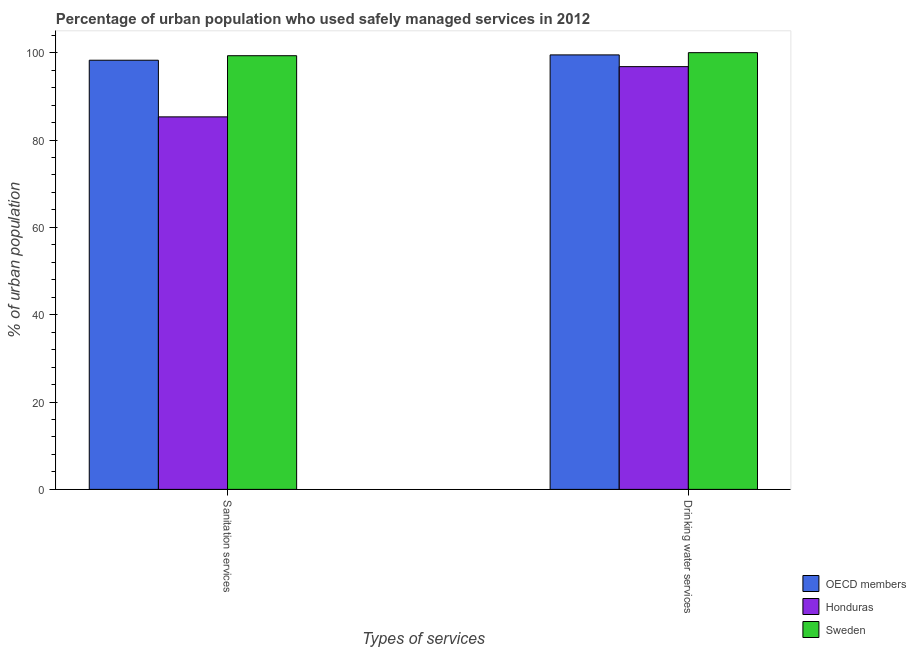How many different coloured bars are there?
Offer a very short reply. 3. How many groups of bars are there?
Offer a very short reply. 2. Are the number of bars per tick equal to the number of legend labels?
Keep it short and to the point. Yes. What is the label of the 2nd group of bars from the left?
Give a very brief answer. Drinking water services. What is the percentage of urban population who used sanitation services in Honduras?
Your response must be concise. 85.3. Across all countries, what is the maximum percentage of urban population who used sanitation services?
Your response must be concise. 99.3. Across all countries, what is the minimum percentage of urban population who used sanitation services?
Ensure brevity in your answer.  85.3. In which country was the percentage of urban population who used drinking water services minimum?
Give a very brief answer. Honduras. What is the total percentage of urban population who used sanitation services in the graph?
Your response must be concise. 282.87. What is the difference between the percentage of urban population who used drinking water services in Sweden and that in Honduras?
Give a very brief answer. 3.2. What is the average percentage of urban population who used sanitation services per country?
Keep it short and to the point. 94.29. What is the difference between the percentage of urban population who used sanitation services and percentage of urban population who used drinking water services in Sweden?
Your answer should be compact. -0.7. In how many countries, is the percentage of urban population who used sanitation services greater than 32 %?
Your answer should be very brief. 3. What is the ratio of the percentage of urban population who used sanitation services in Honduras to that in OECD members?
Keep it short and to the point. 0.87. What does the 2nd bar from the left in Sanitation services represents?
Make the answer very short. Honduras. What does the 2nd bar from the right in Sanitation services represents?
Keep it short and to the point. Honduras. How many countries are there in the graph?
Ensure brevity in your answer.  3. What is the difference between two consecutive major ticks on the Y-axis?
Offer a terse response. 20. Are the values on the major ticks of Y-axis written in scientific E-notation?
Keep it short and to the point. No. Does the graph contain any zero values?
Keep it short and to the point. No. Does the graph contain grids?
Offer a terse response. No. Where does the legend appear in the graph?
Offer a very short reply. Bottom right. How many legend labels are there?
Make the answer very short. 3. What is the title of the graph?
Your response must be concise. Percentage of urban population who used safely managed services in 2012. What is the label or title of the X-axis?
Offer a terse response. Types of services. What is the label or title of the Y-axis?
Your answer should be very brief. % of urban population. What is the % of urban population in OECD members in Sanitation services?
Your response must be concise. 98.27. What is the % of urban population in Honduras in Sanitation services?
Give a very brief answer. 85.3. What is the % of urban population of Sweden in Sanitation services?
Offer a very short reply. 99.3. What is the % of urban population of OECD members in Drinking water services?
Provide a succinct answer. 99.49. What is the % of urban population of Honduras in Drinking water services?
Your answer should be compact. 96.8. What is the % of urban population in Sweden in Drinking water services?
Offer a very short reply. 100. Across all Types of services, what is the maximum % of urban population in OECD members?
Give a very brief answer. 99.49. Across all Types of services, what is the maximum % of urban population in Honduras?
Offer a terse response. 96.8. Across all Types of services, what is the minimum % of urban population of OECD members?
Your response must be concise. 98.27. Across all Types of services, what is the minimum % of urban population of Honduras?
Provide a short and direct response. 85.3. Across all Types of services, what is the minimum % of urban population in Sweden?
Your answer should be compact. 99.3. What is the total % of urban population of OECD members in the graph?
Your answer should be compact. 197.76. What is the total % of urban population in Honduras in the graph?
Provide a short and direct response. 182.1. What is the total % of urban population in Sweden in the graph?
Provide a succinct answer. 199.3. What is the difference between the % of urban population in OECD members in Sanitation services and that in Drinking water services?
Your response must be concise. -1.22. What is the difference between the % of urban population in Sweden in Sanitation services and that in Drinking water services?
Your response must be concise. -0.7. What is the difference between the % of urban population in OECD members in Sanitation services and the % of urban population in Honduras in Drinking water services?
Provide a succinct answer. 1.47. What is the difference between the % of urban population in OECD members in Sanitation services and the % of urban population in Sweden in Drinking water services?
Keep it short and to the point. -1.73. What is the difference between the % of urban population of Honduras in Sanitation services and the % of urban population of Sweden in Drinking water services?
Ensure brevity in your answer.  -14.7. What is the average % of urban population in OECD members per Types of services?
Offer a terse response. 98.88. What is the average % of urban population of Honduras per Types of services?
Provide a succinct answer. 91.05. What is the average % of urban population in Sweden per Types of services?
Your response must be concise. 99.65. What is the difference between the % of urban population of OECD members and % of urban population of Honduras in Sanitation services?
Provide a succinct answer. 12.97. What is the difference between the % of urban population of OECD members and % of urban population of Sweden in Sanitation services?
Offer a terse response. -1.03. What is the difference between the % of urban population of OECD members and % of urban population of Honduras in Drinking water services?
Provide a succinct answer. 2.69. What is the difference between the % of urban population in OECD members and % of urban population in Sweden in Drinking water services?
Offer a very short reply. -0.51. What is the difference between the % of urban population of Honduras and % of urban population of Sweden in Drinking water services?
Your response must be concise. -3.2. What is the ratio of the % of urban population in OECD members in Sanitation services to that in Drinking water services?
Your answer should be very brief. 0.99. What is the ratio of the % of urban population of Honduras in Sanitation services to that in Drinking water services?
Provide a short and direct response. 0.88. What is the difference between the highest and the second highest % of urban population of OECD members?
Provide a short and direct response. 1.22. What is the difference between the highest and the second highest % of urban population of Honduras?
Make the answer very short. 11.5. What is the difference between the highest and the lowest % of urban population in OECD members?
Ensure brevity in your answer.  1.22. What is the difference between the highest and the lowest % of urban population of Honduras?
Keep it short and to the point. 11.5. What is the difference between the highest and the lowest % of urban population of Sweden?
Your answer should be very brief. 0.7. 